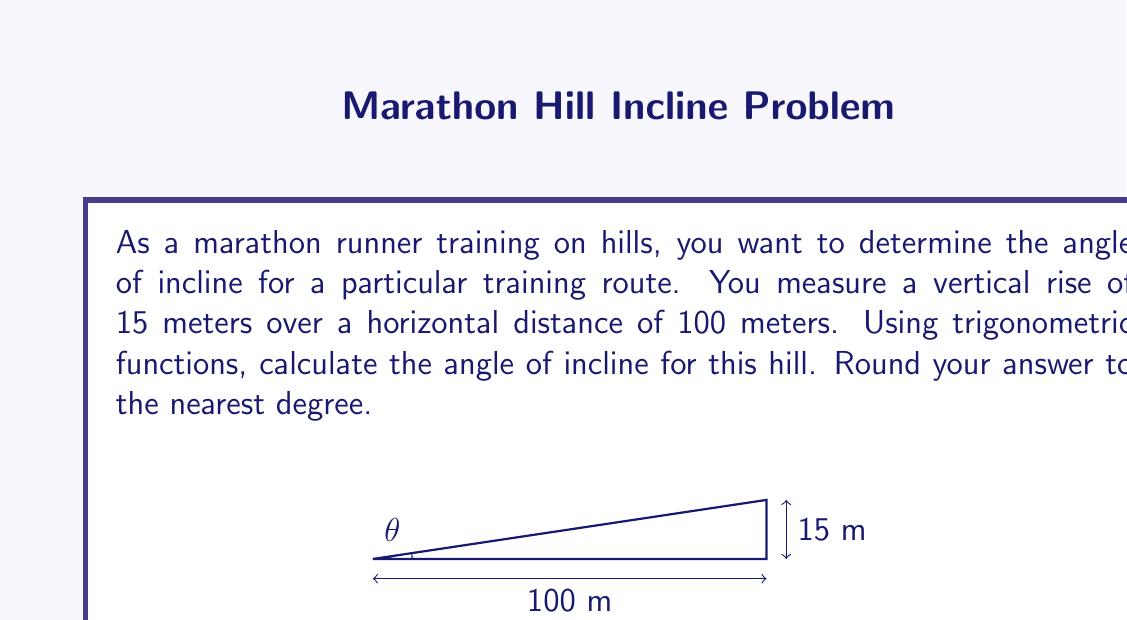Solve this math problem. To solve this problem, we'll use the tangent function, which relates the opposite side to the adjacent side in a right triangle. Let's approach this step-by-step:

1) In this case, we have:
   - Opposite side (vertical rise) = 15 meters
   - Adjacent side (horizontal distance) = 100 meters

2) The tangent of the angle $\theta$ is defined as:

   $$\tan(\theta) = \frac{\text{opposite}}{\text{adjacent}}$$

3) Substituting our values:

   $$\tan(\theta) = \frac{15}{100} = 0.15$$

4) To find $\theta$, we need to use the inverse tangent function (arctan or $\tan^{-1}$):

   $$\theta = \tan^{-1}(0.15)$$

5) Using a calculator or computer:

   $$\theta \approx 8.53°$$

6) Rounding to the nearest degree:

   $$\theta \approx 9°$$

Thus, the angle of incline for this hill is approximately 9 degrees.
Answer: $9°$ 